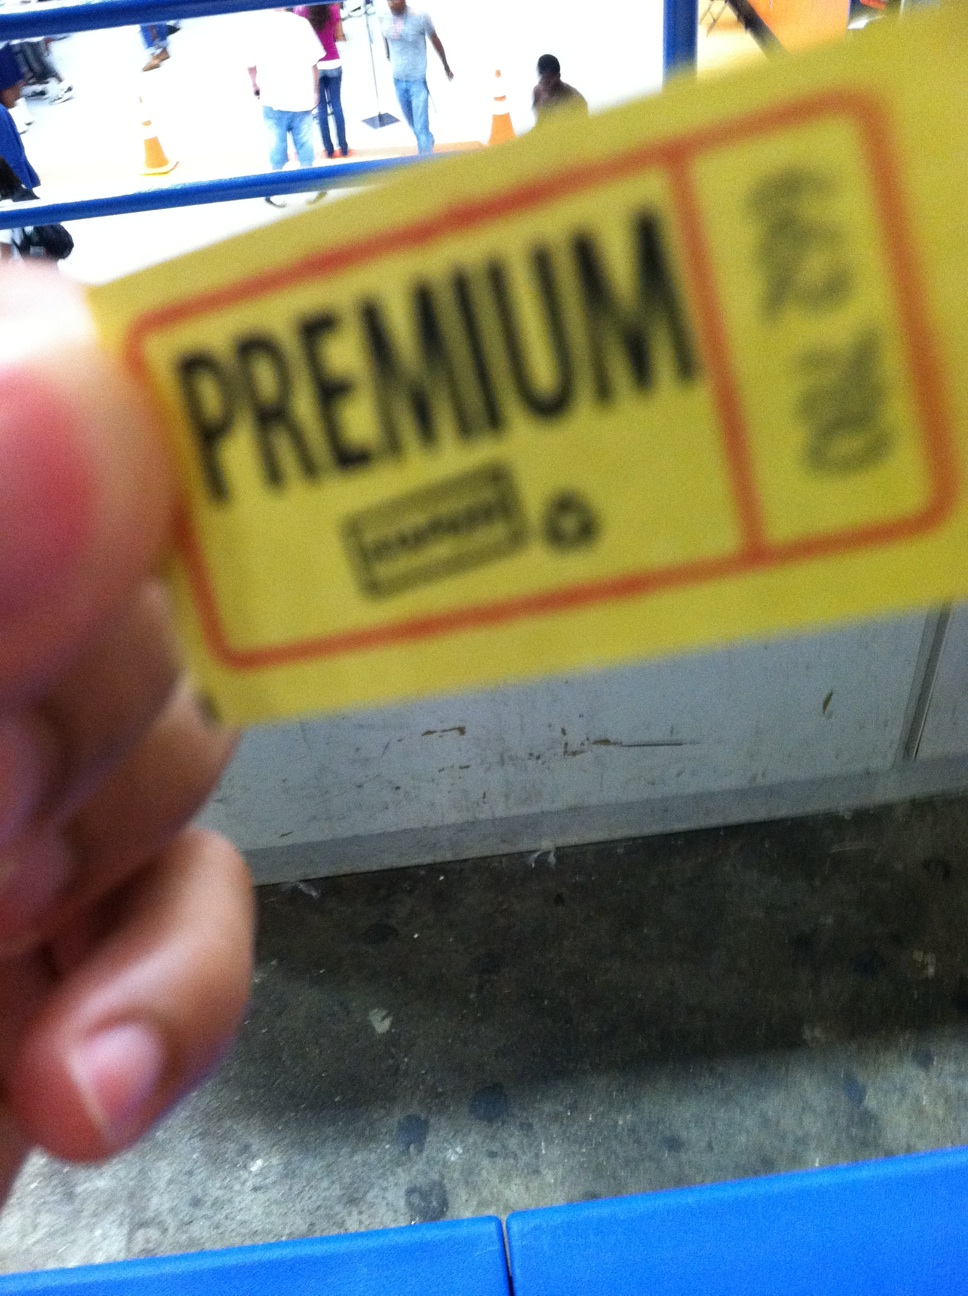How would you describe the environment in which the photo was taken? The image has a shallow depth of field, focusing on the card and leaving the background blurred. However, we can see a hint of an indoor setting, possibly a station or a public area with people walking around, indicated by the portion of a blue structure which might be a seat or barrier and the appearance of floor tiles. 